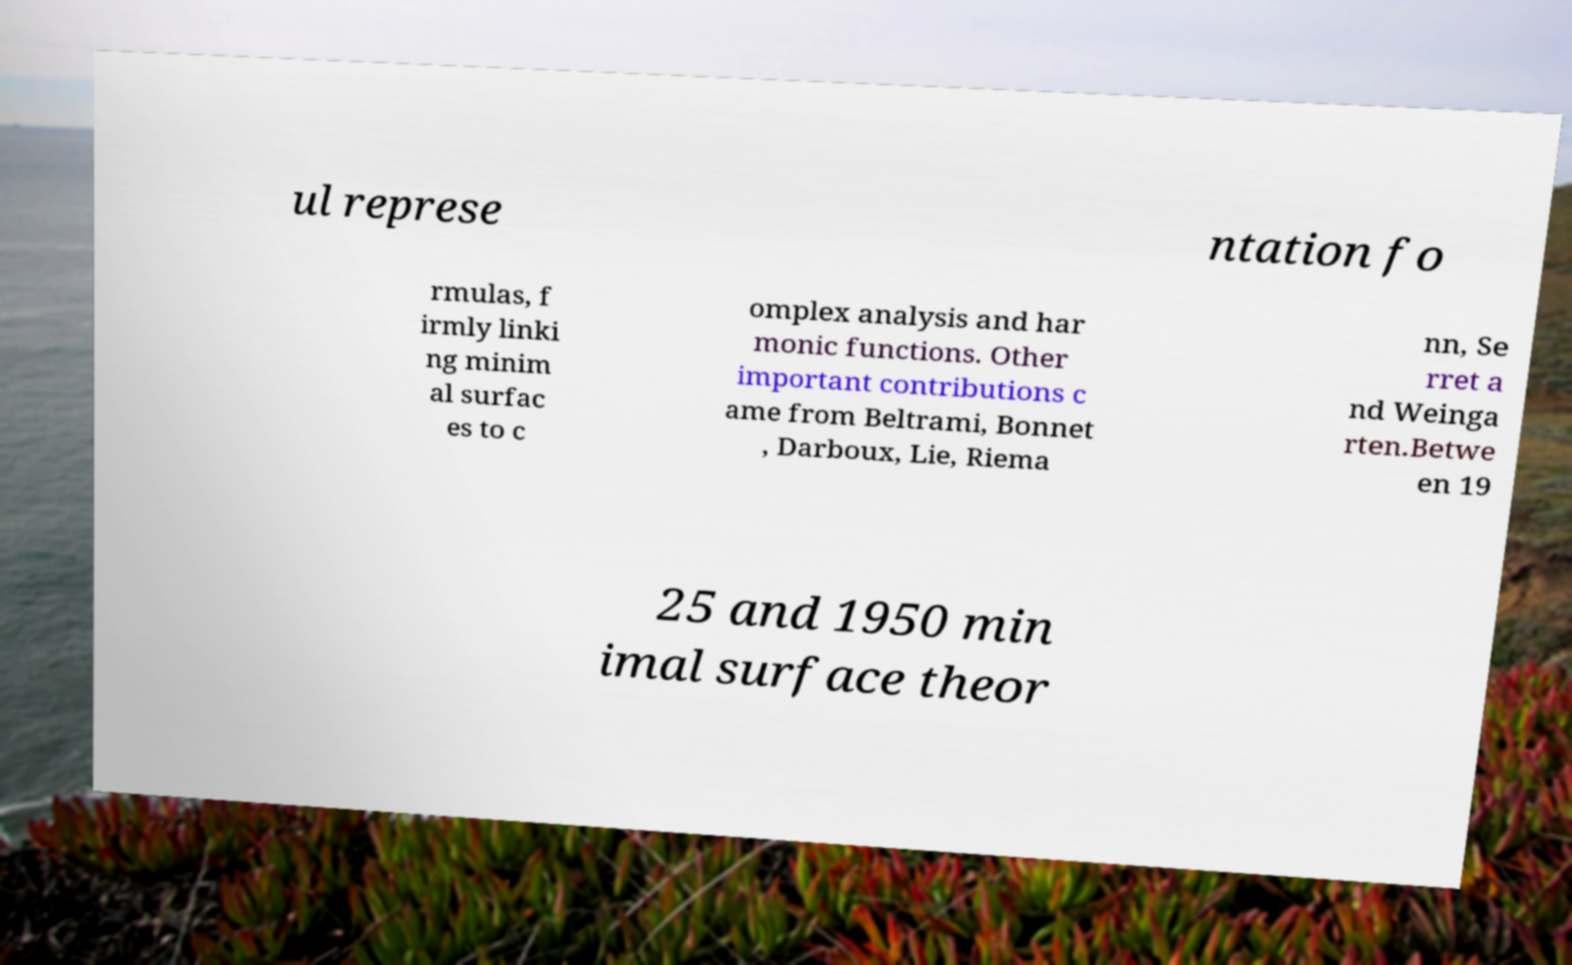Could you assist in decoding the text presented in this image and type it out clearly? ul represe ntation fo rmulas, f irmly linki ng minim al surfac es to c omplex analysis and har monic functions. Other important contributions c ame from Beltrami, Bonnet , Darboux, Lie, Riema nn, Se rret a nd Weinga rten.Betwe en 19 25 and 1950 min imal surface theor 